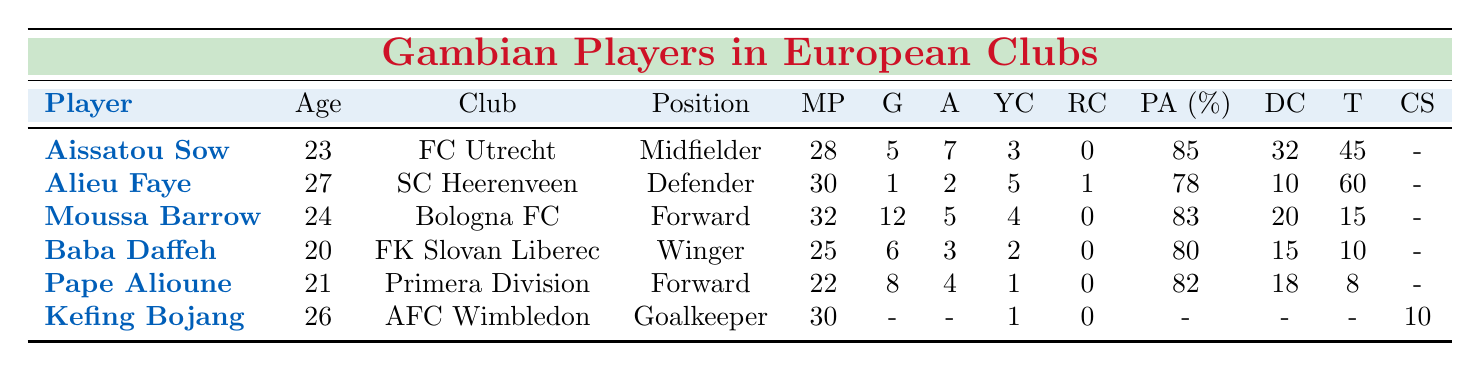What is the highest number of goals scored by a player? The player with the highest number of goals is Moussa Barrow, who scored 12 goals for Bologna FC.
Answer: 12 How many yellow cards did Alieu Faye receive? Alieu Faye received 5 yellow cards while playing for SC Heerenveen.
Answer: 5 Which player has the best passing accuracy? Aissatou Sow has the best passing accuracy at 85%.
Answer: 85% What is the total number of assists made by all players combined? The total number of assists is calculated by adding all individual assists: 7 (Sow) + 2 (Faye) + 5 (Barrow) + 3 (Daffeh) + 4 (Alioune) = 21.
Answer: 21 How many players have scored more than 5 goals? Three players have scored more than 5 goals: Moussa Barrow (12), Pape Alioune (8), and Baba Daffeh (6).
Answer: 3 Which player has the most yellow cards and how many? Alieu Faye has the most yellow cards with a total of 5.
Answer: 5 What is the average age of the players listed? To find the average age, sum the ages of the players: 23 (Sow) + 27 (Faye) + 24 (Barrow) + 20 (Daffeh) + 21 (Alioune) + 26 (Bojang) = 141, then divide by 6 (total players), which gives 141/6 = 23.5.
Answer: 23.5 Is there a player with zero red cards? Yes, there are multiple players with zero red cards, including Aissatou Sow, Moussa Barrow, Baba Daffeh, and Pape Alioune.
Answer: Yes Which player has the most matches played? Moussa Barrow has played the most matches, totaling 32 for Bologna FC.
Answer: 32 How many total clean sheets did Kefing Bojang have? Kefing Bojang had a total of 10 clean sheets as noted in the table.
Answer: 10 